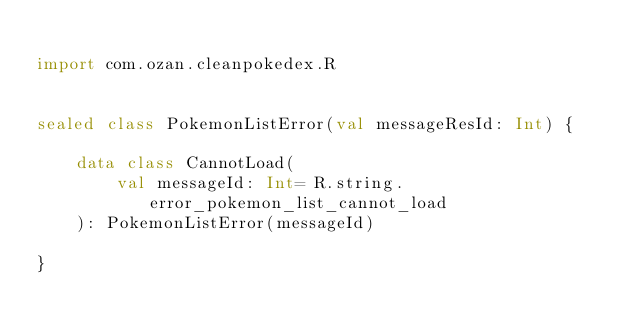Convert code to text. <code><loc_0><loc_0><loc_500><loc_500><_Kotlin_>
import com.ozan.cleanpokedex.R


sealed class PokemonListError(val messageResId: Int) {

    data class CannotLoad(
        val messageId: Int= R.string.error_pokemon_list_cannot_load
    ): PokemonListError(messageId)

}</code> 